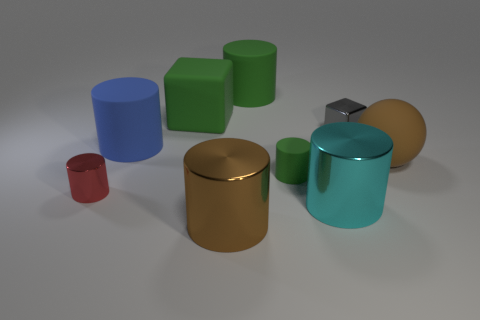The large thing that is the same color as the matte cube is what shape?
Your response must be concise. Cylinder. Are there fewer small metallic blocks that are in front of the tiny red cylinder than large blue rubber objects?
Give a very brief answer. Yes. Is the brown metal object the same shape as the red metallic thing?
Your answer should be very brief. Yes. The red thing that is the same material as the large cyan thing is what size?
Provide a short and direct response. Small. Is the number of large things less than the number of big red blocks?
Provide a succinct answer. No. What number of small objects are cyan rubber cylinders or gray metallic things?
Keep it short and to the point. 1. What number of things are in front of the small rubber thing and left of the large green matte cube?
Your answer should be compact. 1. Are there more tiny purple metal objects than small gray shiny cubes?
Make the answer very short. No. How many other objects are the same shape as the small green thing?
Provide a succinct answer. 5. Is the tiny rubber object the same color as the rubber cube?
Offer a terse response. Yes. 